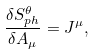<formula> <loc_0><loc_0><loc_500><loc_500>\frac { \delta S ^ { \theta } _ { p h } } { \delta A _ { \mu } } = J ^ { \mu } ,</formula> 